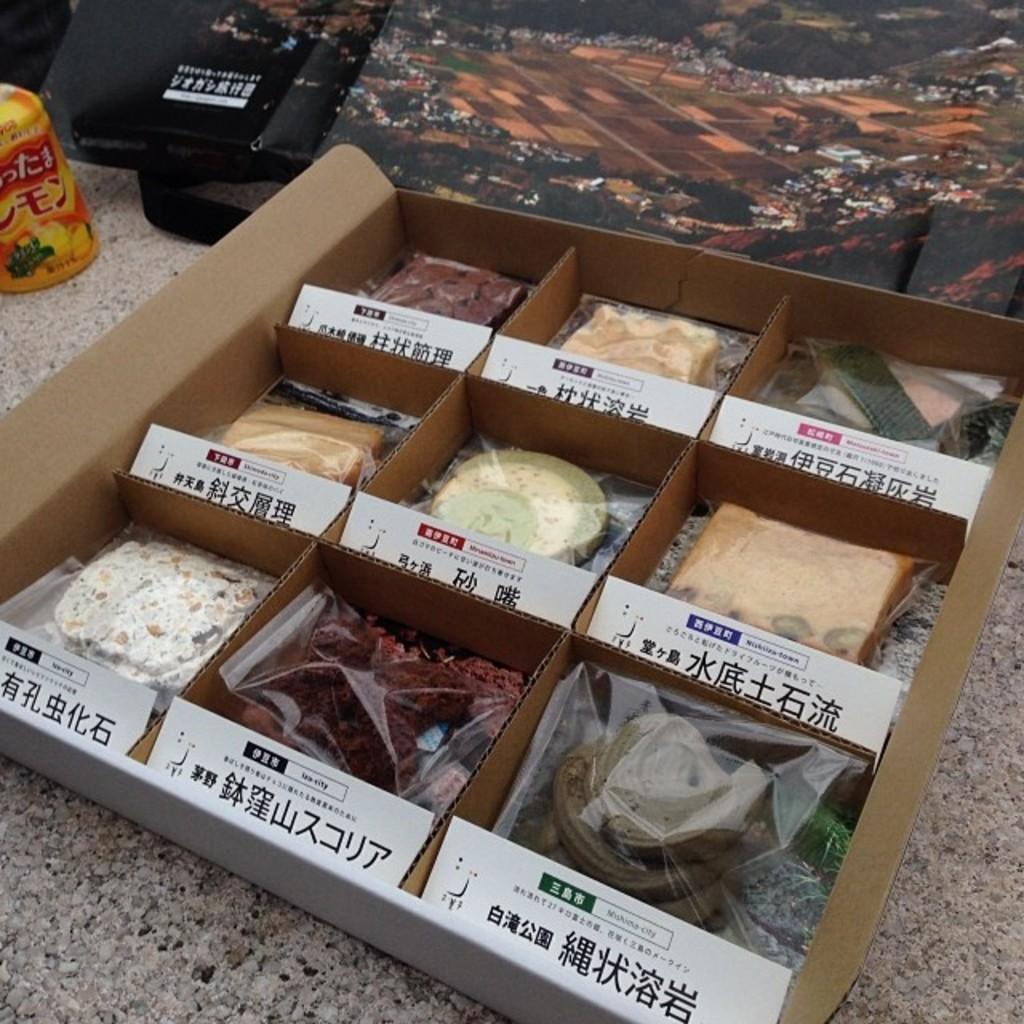In one or two sentences, can you explain what this image depicts? In this image we can see a box with some food items and text on the box and there are few objects on the floor. 